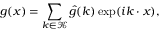Convert formula to latex. <formula><loc_0><loc_0><loc_500><loc_500>g ( \boldsymbol x ) = \sum _ { \boldsymbol k \in \mathcal { K } } \hat { g } ( \boldsymbol k ) \exp ( i \boldsymbol k \cdot \boldsymbol x ) ,</formula> 